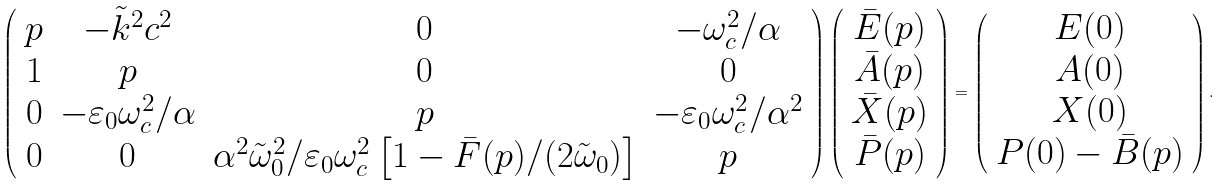<formula> <loc_0><loc_0><loc_500><loc_500>\left ( \begin{array} { c c c c } p & - \tilde { k } ^ { 2 } c ^ { 2 } & 0 & - \omega _ { c } ^ { 2 } / \alpha \\ 1 & p & 0 & 0 \\ 0 & - \varepsilon _ { 0 } \omega _ { c } ^ { 2 } / \alpha & p & - \varepsilon _ { 0 } \omega _ { c } ^ { 2 } / \alpha ^ { 2 } \\ 0 & 0 & \alpha ^ { 2 } \tilde { \omega } _ { 0 } ^ { 2 } / \varepsilon _ { 0 } \omega _ { c } ^ { 2 } \left [ 1 - \bar { F } ( p ) / ( 2 \tilde { \omega } _ { 0 } ) \right ] & p \end{array} \right ) \left ( \begin{array} { c } \bar { E } ( p ) \\ \bar { A } ( p ) \\ \bar { X } ( p ) \\ \bar { P } ( p ) \end{array} \right ) = \left ( \begin{array} { c } E ( 0 ) \\ A ( 0 ) \\ X ( 0 ) \\ P ( 0 ) - \bar { B } ( p ) \end{array} \right ) .</formula> 